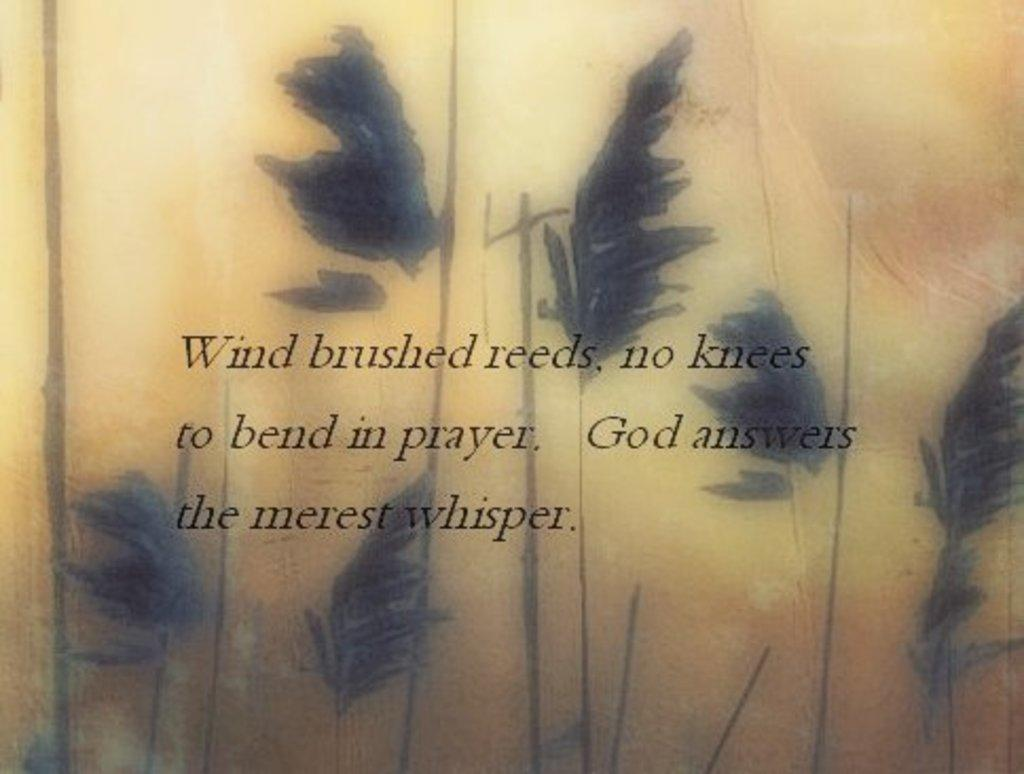What is the focus of the image? The image is zoomed in on an object. What is the object in the center of the image? The object appears to be a paper. What can be seen on the paper? The paper has a picture of leaves on it. Is there any text on the paper? Yes, there is text printed on the paper. How many teeth can be seen on the paper in the image? There are no teeth depicted on the paper in the image; it features a picture of leaves. 